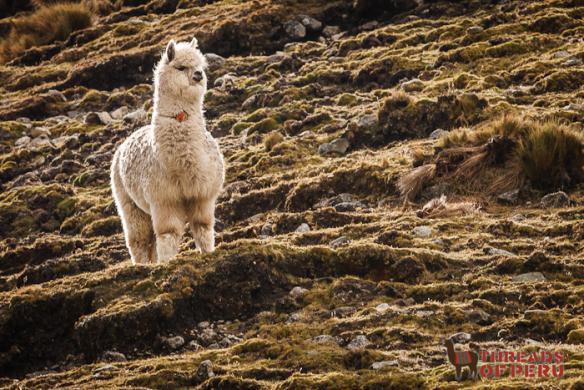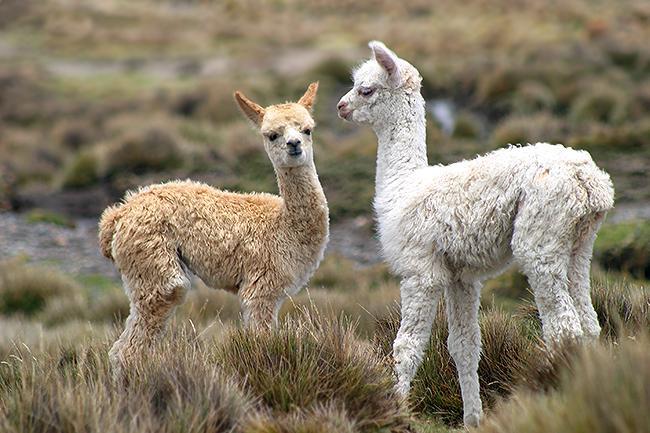The first image is the image on the left, the second image is the image on the right. Evaluate the accuracy of this statement regarding the images: "One llama is not standing on four legs.". Is it true? Answer yes or no. No. The first image is the image on the left, the second image is the image on the right. Given the left and right images, does the statement "In one image, two llamas - including a brown-and-white one - are next to a rustic stone wall." hold true? Answer yes or no. No. 